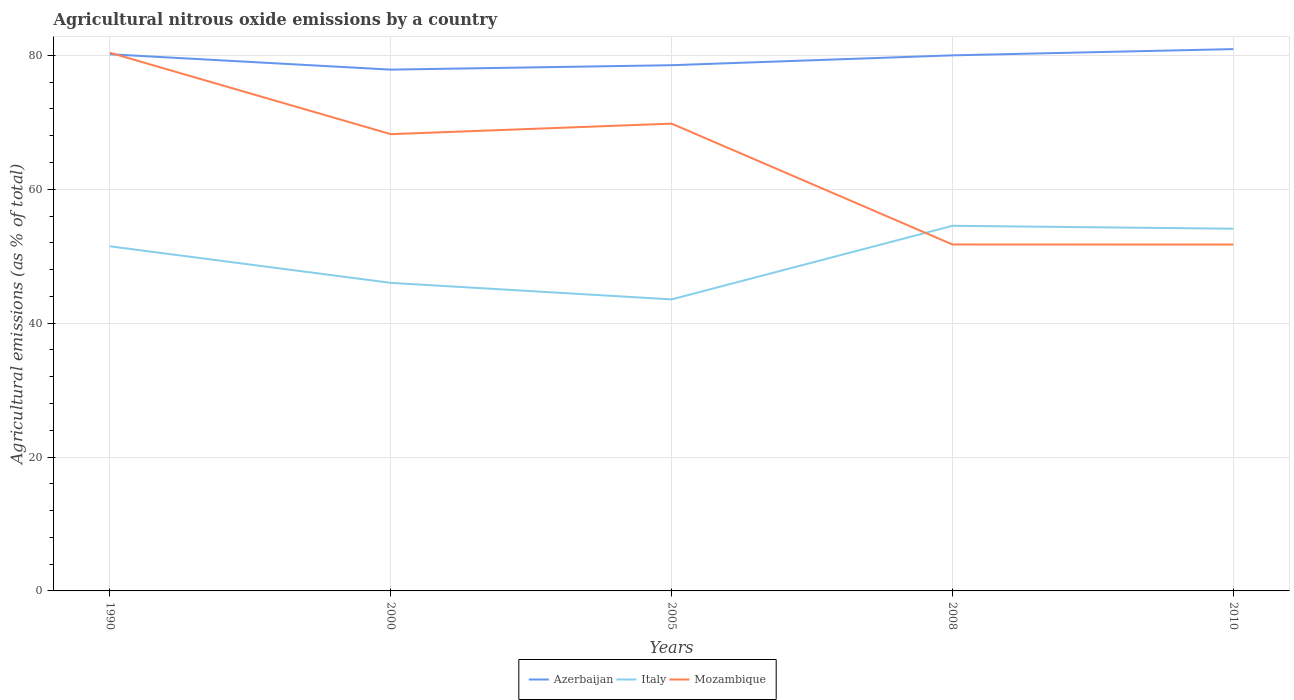Does the line corresponding to Azerbaijan intersect with the line corresponding to Mozambique?
Offer a terse response. Yes. Is the number of lines equal to the number of legend labels?
Ensure brevity in your answer.  Yes. Across all years, what is the maximum amount of agricultural nitrous oxide emitted in Italy?
Ensure brevity in your answer.  43.55. What is the total amount of agricultural nitrous oxide emitted in Mozambique in the graph?
Your response must be concise. 12.16. What is the difference between the highest and the second highest amount of agricultural nitrous oxide emitted in Italy?
Your answer should be very brief. 10.99. How many years are there in the graph?
Offer a terse response. 5. How many legend labels are there?
Your answer should be compact. 3. What is the title of the graph?
Your answer should be very brief. Agricultural nitrous oxide emissions by a country. Does "Isle of Man" appear as one of the legend labels in the graph?
Keep it short and to the point. No. What is the label or title of the X-axis?
Give a very brief answer. Years. What is the label or title of the Y-axis?
Offer a terse response. Agricultural emissions (as % of total). What is the Agricultural emissions (as % of total) in Azerbaijan in 1990?
Your answer should be very brief. 80.17. What is the Agricultural emissions (as % of total) of Italy in 1990?
Offer a terse response. 51.48. What is the Agricultural emissions (as % of total) in Mozambique in 1990?
Provide a succinct answer. 80.39. What is the Agricultural emissions (as % of total) of Azerbaijan in 2000?
Ensure brevity in your answer.  77.87. What is the Agricultural emissions (as % of total) in Italy in 2000?
Provide a succinct answer. 46.02. What is the Agricultural emissions (as % of total) in Mozambique in 2000?
Your response must be concise. 68.23. What is the Agricultural emissions (as % of total) of Azerbaijan in 2005?
Give a very brief answer. 78.53. What is the Agricultural emissions (as % of total) in Italy in 2005?
Make the answer very short. 43.55. What is the Agricultural emissions (as % of total) of Mozambique in 2005?
Offer a terse response. 69.8. What is the Agricultural emissions (as % of total) in Azerbaijan in 2008?
Provide a succinct answer. 80. What is the Agricultural emissions (as % of total) of Italy in 2008?
Ensure brevity in your answer.  54.54. What is the Agricultural emissions (as % of total) of Mozambique in 2008?
Provide a short and direct response. 51.75. What is the Agricultural emissions (as % of total) in Azerbaijan in 2010?
Your answer should be very brief. 80.94. What is the Agricultural emissions (as % of total) of Italy in 2010?
Provide a short and direct response. 54.1. What is the Agricultural emissions (as % of total) of Mozambique in 2010?
Your answer should be very brief. 51.74. Across all years, what is the maximum Agricultural emissions (as % of total) of Azerbaijan?
Ensure brevity in your answer.  80.94. Across all years, what is the maximum Agricultural emissions (as % of total) of Italy?
Ensure brevity in your answer.  54.54. Across all years, what is the maximum Agricultural emissions (as % of total) in Mozambique?
Your answer should be very brief. 80.39. Across all years, what is the minimum Agricultural emissions (as % of total) in Azerbaijan?
Provide a short and direct response. 77.87. Across all years, what is the minimum Agricultural emissions (as % of total) in Italy?
Offer a terse response. 43.55. Across all years, what is the minimum Agricultural emissions (as % of total) of Mozambique?
Offer a very short reply. 51.74. What is the total Agricultural emissions (as % of total) of Azerbaijan in the graph?
Offer a terse response. 397.51. What is the total Agricultural emissions (as % of total) of Italy in the graph?
Give a very brief answer. 249.69. What is the total Agricultural emissions (as % of total) in Mozambique in the graph?
Your answer should be compact. 321.92. What is the difference between the Agricultural emissions (as % of total) of Azerbaijan in 1990 and that in 2000?
Give a very brief answer. 2.3. What is the difference between the Agricultural emissions (as % of total) in Italy in 1990 and that in 2000?
Your answer should be compact. 5.46. What is the difference between the Agricultural emissions (as % of total) of Mozambique in 1990 and that in 2000?
Your answer should be compact. 12.16. What is the difference between the Agricultural emissions (as % of total) in Azerbaijan in 1990 and that in 2005?
Provide a short and direct response. 1.64. What is the difference between the Agricultural emissions (as % of total) in Italy in 1990 and that in 2005?
Your answer should be compact. 7.93. What is the difference between the Agricultural emissions (as % of total) of Mozambique in 1990 and that in 2005?
Offer a terse response. 10.59. What is the difference between the Agricultural emissions (as % of total) in Azerbaijan in 1990 and that in 2008?
Give a very brief answer. 0.16. What is the difference between the Agricultural emissions (as % of total) in Italy in 1990 and that in 2008?
Give a very brief answer. -3.06. What is the difference between the Agricultural emissions (as % of total) in Mozambique in 1990 and that in 2008?
Make the answer very short. 28.64. What is the difference between the Agricultural emissions (as % of total) of Azerbaijan in 1990 and that in 2010?
Your response must be concise. -0.77. What is the difference between the Agricultural emissions (as % of total) in Italy in 1990 and that in 2010?
Offer a terse response. -2.63. What is the difference between the Agricultural emissions (as % of total) in Mozambique in 1990 and that in 2010?
Offer a terse response. 28.65. What is the difference between the Agricultural emissions (as % of total) in Azerbaijan in 2000 and that in 2005?
Make the answer very short. -0.66. What is the difference between the Agricultural emissions (as % of total) of Italy in 2000 and that in 2005?
Your answer should be very brief. 2.47. What is the difference between the Agricultural emissions (as % of total) in Mozambique in 2000 and that in 2005?
Offer a very short reply. -1.57. What is the difference between the Agricultural emissions (as % of total) of Azerbaijan in 2000 and that in 2008?
Ensure brevity in your answer.  -2.13. What is the difference between the Agricultural emissions (as % of total) of Italy in 2000 and that in 2008?
Keep it short and to the point. -8.52. What is the difference between the Agricultural emissions (as % of total) of Mozambique in 2000 and that in 2008?
Offer a terse response. 16.48. What is the difference between the Agricultural emissions (as % of total) of Azerbaijan in 2000 and that in 2010?
Your response must be concise. -3.07. What is the difference between the Agricultural emissions (as % of total) in Italy in 2000 and that in 2010?
Offer a very short reply. -8.09. What is the difference between the Agricultural emissions (as % of total) in Mozambique in 2000 and that in 2010?
Ensure brevity in your answer.  16.49. What is the difference between the Agricultural emissions (as % of total) of Azerbaijan in 2005 and that in 2008?
Your response must be concise. -1.47. What is the difference between the Agricultural emissions (as % of total) in Italy in 2005 and that in 2008?
Your answer should be compact. -10.99. What is the difference between the Agricultural emissions (as % of total) of Mozambique in 2005 and that in 2008?
Make the answer very short. 18.05. What is the difference between the Agricultural emissions (as % of total) in Azerbaijan in 2005 and that in 2010?
Your answer should be compact. -2.41. What is the difference between the Agricultural emissions (as % of total) in Italy in 2005 and that in 2010?
Provide a succinct answer. -10.56. What is the difference between the Agricultural emissions (as % of total) of Mozambique in 2005 and that in 2010?
Your answer should be compact. 18.06. What is the difference between the Agricultural emissions (as % of total) of Azerbaijan in 2008 and that in 2010?
Provide a short and direct response. -0.93. What is the difference between the Agricultural emissions (as % of total) of Italy in 2008 and that in 2010?
Provide a succinct answer. 0.44. What is the difference between the Agricultural emissions (as % of total) of Mozambique in 2008 and that in 2010?
Ensure brevity in your answer.  0.01. What is the difference between the Agricultural emissions (as % of total) in Azerbaijan in 1990 and the Agricultural emissions (as % of total) in Italy in 2000?
Your response must be concise. 34.15. What is the difference between the Agricultural emissions (as % of total) in Azerbaijan in 1990 and the Agricultural emissions (as % of total) in Mozambique in 2000?
Provide a short and direct response. 11.94. What is the difference between the Agricultural emissions (as % of total) of Italy in 1990 and the Agricultural emissions (as % of total) of Mozambique in 2000?
Make the answer very short. -16.75. What is the difference between the Agricultural emissions (as % of total) of Azerbaijan in 1990 and the Agricultural emissions (as % of total) of Italy in 2005?
Ensure brevity in your answer.  36.62. What is the difference between the Agricultural emissions (as % of total) in Azerbaijan in 1990 and the Agricultural emissions (as % of total) in Mozambique in 2005?
Offer a terse response. 10.37. What is the difference between the Agricultural emissions (as % of total) in Italy in 1990 and the Agricultural emissions (as % of total) in Mozambique in 2005?
Give a very brief answer. -18.32. What is the difference between the Agricultural emissions (as % of total) in Azerbaijan in 1990 and the Agricultural emissions (as % of total) in Italy in 2008?
Keep it short and to the point. 25.63. What is the difference between the Agricultural emissions (as % of total) in Azerbaijan in 1990 and the Agricultural emissions (as % of total) in Mozambique in 2008?
Give a very brief answer. 28.42. What is the difference between the Agricultural emissions (as % of total) of Italy in 1990 and the Agricultural emissions (as % of total) of Mozambique in 2008?
Keep it short and to the point. -0.27. What is the difference between the Agricultural emissions (as % of total) in Azerbaijan in 1990 and the Agricultural emissions (as % of total) in Italy in 2010?
Your answer should be compact. 26.06. What is the difference between the Agricultural emissions (as % of total) in Azerbaijan in 1990 and the Agricultural emissions (as % of total) in Mozambique in 2010?
Provide a short and direct response. 28.42. What is the difference between the Agricultural emissions (as % of total) in Italy in 1990 and the Agricultural emissions (as % of total) in Mozambique in 2010?
Make the answer very short. -0.27. What is the difference between the Agricultural emissions (as % of total) of Azerbaijan in 2000 and the Agricultural emissions (as % of total) of Italy in 2005?
Your response must be concise. 34.32. What is the difference between the Agricultural emissions (as % of total) of Azerbaijan in 2000 and the Agricultural emissions (as % of total) of Mozambique in 2005?
Make the answer very short. 8.07. What is the difference between the Agricultural emissions (as % of total) of Italy in 2000 and the Agricultural emissions (as % of total) of Mozambique in 2005?
Ensure brevity in your answer.  -23.78. What is the difference between the Agricultural emissions (as % of total) of Azerbaijan in 2000 and the Agricultural emissions (as % of total) of Italy in 2008?
Your answer should be compact. 23.33. What is the difference between the Agricultural emissions (as % of total) of Azerbaijan in 2000 and the Agricultural emissions (as % of total) of Mozambique in 2008?
Ensure brevity in your answer.  26.12. What is the difference between the Agricultural emissions (as % of total) in Italy in 2000 and the Agricultural emissions (as % of total) in Mozambique in 2008?
Your answer should be very brief. -5.73. What is the difference between the Agricultural emissions (as % of total) of Azerbaijan in 2000 and the Agricultural emissions (as % of total) of Italy in 2010?
Provide a short and direct response. 23.77. What is the difference between the Agricultural emissions (as % of total) of Azerbaijan in 2000 and the Agricultural emissions (as % of total) of Mozambique in 2010?
Your response must be concise. 26.13. What is the difference between the Agricultural emissions (as % of total) of Italy in 2000 and the Agricultural emissions (as % of total) of Mozambique in 2010?
Offer a very short reply. -5.73. What is the difference between the Agricultural emissions (as % of total) of Azerbaijan in 2005 and the Agricultural emissions (as % of total) of Italy in 2008?
Offer a terse response. 23.99. What is the difference between the Agricultural emissions (as % of total) of Azerbaijan in 2005 and the Agricultural emissions (as % of total) of Mozambique in 2008?
Your answer should be compact. 26.78. What is the difference between the Agricultural emissions (as % of total) of Italy in 2005 and the Agricultural emissions (as % of total) of Mozambique in 2008?
Your response must be concise. -8.2. What is the difference between the Agricultural emissions (as % of total) of Azerbaijan in 2005 and the Agricultural emissions (as % of total) of Italy in 2010?
Give a very brief answer. 24.43. What is the difference between the Agricultural emissions (as % of total) in Azerbaijan in 2005 and the Agricultural emissions (as % of total) in Mozambique in 2010?
Ensure brevity in your answer.  26.79. What is the difference between the Agricultural emissions (as % of total) in Italy in 2005 and the Agricultural emissions (as % of total) in Mozambique in 2010?
Provide a succinct answer. -8.19. What is the difference between the Agricultural emissions (as % of total) of Azerbaijan in 2008 and the Agricultural emissions (as % of total) of Italy in 2010?
Give a very brief answer. 25.9. What is the difference between the Agricultural emissions (as % of total) in Azerbaijan in 2008 and the Agricultural emissions (as % of total) in Mozambique in 2010?
Make the answer very short. 28.26. What is the difference between the Agricultural emissions (as % of total) in Italy in 2008 and the Agricultural emissions (as % of total) in Mozambique in 2010?
Your answer should be very brief. 2.8. What is the average Agricultural emissions (as % of total) of Azerbaijan per year?
Your response must be concise. 79.5. What is the average Agricultural emissions (as % of total) in Italy per year?
Provide a succinct answer. 49.94. What is the average Agricultural emissions (as % of total) in Mozambique per year?
Your response must be concise. 64.38. In the year 1990, what is the difference between the Agricultural emissions (as % of total) of Azerbaijan and Agricultural emissions (as % of total) of Italy?
Provide a succinct answer. 28.69. In the year 1990, what is the difference between the Agricultural emissions (as % of total) in Azerbaijan and Agricultural emissions (as % of total) in Mozambique?
Keep it short and to the point. -0.22. In the year 1990, what is the difference between the Agricultural emissions (as % of total) in Italy and Agricultural emissions (as % of total) in Mozambique?
Ensure brevity in your answer.  -28.91. In the year 2000, what is the difference between the Agricultural emissions (as % of total) of Azerbaijan and Agricultural emissions (as % of total) of Italy?
Give a very brief answer. 31.85. In the year 2000, what is the difference between the Agricultural emissions (as % of total) in Azerbaijan and Agricultural emissions (as % of total) in Mozambique?
Ensure brevity in your answer.  9.64. In the year 2000, what is the difference between the Agricultural emissions (as % of total) of Italy and Agricultural emissions (as % of total) of Mozambique?
Your answer should be very brief. -22.21. In the year 2005, what is the difference between the Agricultural emissions (as % of total) of Azerbaijan and Agricultural emissions (as % of total) of Italy?
Provide a succinct answer. 34.98. In the year 2005, what is the difference between the Agricultural emissions (as % of total) in Azerbaijan and Agricultural emissions (as % of total) in Mozambique?
Give a very brief answer. 8.73. In the year 2005, what is the difference between the Agricultural emissions (as % of total) of Italy and Agricultural emissions (as % of total) of Mozambique?
Offer a terse response. -26.25. In the year 2008, what is the difference between the Agricultural emissions (as % of total) of Azerbaijan and Agricultural emissions (as % of total) of Italy?
Make the answer very short. 25.46. In the year 2008, what is the difference between the Agricultural emissions (as % of total) of Azerbaijan and Agricultural emissions (as % of total) of Mozambique?
Give a very brief answer. 28.25. In the year 2008, what is the difference between the Agricultural emissions (as % of total) in Italy and Agricultural emissions (as % of total) in Mozambique?
Offer a terse response. 2.79. In the year 2010, what is the difference between the Agricultural emissions (as % of total) in Azerbaijan and Agricultural emissions (as % of total) in Italy?
Provide a succinct answer. 26.83. In the year 2010, what is the difference between the Agricultural emissions (as % of total) of Azerbaijan and Agricultural emissions (as % of total) of Mozambique?
Your answer should be very brief. 29.19. In the year 2010, what is the difference between the Agricultural emissions (as % of total) of Italy and Agricultural emissions (as % of total) of Mozambique?
Offer a very short reply. 2.36. What is the ratio of the Agricultural emissions (as % of total) in Azerbaijan in 1990 to that in 2000?
Make the answer very short. 1.03. What is the ratio of the Agricultural emissions (as % of total) in Italy in 1990 to that in 2000?
Provide a short and direct response. 1.12. What is the ratio of the Agricultural emissions (as % of total) in Mozambique in 1990 to that in 2000?
Make the answer very short. 1.18. What is the ratio of the Agricultural emissions (as % of total) of Azerbaijan in 1990 to that in 2005?
Offer a very short reply. 1.02. What is the ratio of the Agricultural emissions (as % of total) of Italy in 1990 to that in 2005?
Your response must be concise. 1.18. What is the ratio of the Agricultural emissions (as % of total) in Mozambique in 1990 to that in 2005?
Your response must be concise. 1.15. What is the ratio of the Agricultural emissions (as % of total) in Azerbaijan in 1990 to that in 2008?
Make the answer very short. 1. What is the ratio of the Agricultural emissions (as % of total) in Italy in 1990 to that in 2008?
Give a very brief answer. 0.94. What is the ratio of the Agricultural emissions (as % of total) of Mozambique in 1990 to that in 2008?
Offer a terse response. 1.55. What is the ratio of the Agricultural emissions (as % of total) of Italy in 1990 to that in 2010?
Give a very brief answer. 0.95. What is the ratio of the Agricultural emissions (as % of total) of Mozambique in 1990 to that in 2010?
Provide a short and direct response. 1.55. What is the ratio of the Agricultural emissions (as % of total) of Azerbaijan in 2000 to that in 2005?
Offer a very short reply. 0.99. What is the ratio of the Agricultural emissions (as % of total) in Italy in 2000 to that in 2005?
Ensure brevity in your answer.  1.06. What is the ratio of the Agricultural emissions (as % of total) in Mozambique in 2000 to that in 2005?
Provide a succinct answer. 0.98. What is the ratio of the Agricultural emissions (as % of total) in Azerbaijan in 2000 to that in 2008?
Make the answer very short. 0.97. What is the ratio of the Agricultural emissions (as % of total) in Italy in 2000 to that in 2008?
Your response must be concise. 0.84. What is the ratio of the Agricultural emissions (as % of total) in Mozambique in 2000 to that in 2008?
Provide a short and direct response. 1.32. What is the ratio of the Agricultural emissions (as % of total) of Azerbaijan in 2000 to that in 2010?
Keep it short and to the point. 0.96. What is the ratio of the Agricultural emissions (as % of total) in Italy in 2000 to that in 2010?
Offer a very short reply. 0.85. What is the ratio of the Agricultural emissions (as % of total) of Mozambique in 2000 to that in 2010?
Your response must be concise. 1.32. What is the ratio of the Agricultural emissions (as % of total) of Azerbaijan in 2005 to that in 2008?
Provide a succinct answer. 0.98. What is the ratio of the Agricultural emissions (as % of total) in Italy in 2005 to that in 2008?
Your response must be concise. 0.8. What is the ratio of the Agricultural emissions (as % of total) in Mozambique in 2005 to that in 2008?
Your answer should be compact. 1.35. What is the ratio of the Agricultural emissions (as % of total) in Azerbaijan in 2005 to that in 2010?
Ensure brevity in your answer.  0.97. What is the ratio of the Agricultural emissions (as % of total) in Italy in 2005 to that in 2010?
Give a very brief answer. 0.8. What is the ratio of the Agricultural emissions (as % of total) of Mozambique in 2005 to that in 2010?
Give a very brief answer. 1.35. What is the ratio of the Agricultural emissions (as % of total) of Mozambique in 2008 to that in 2010?
Keep it short and to the point. 1. What is the difference between the highest and the second highest Agricultural emissions (as % of total) of Azerbaijan?
Ensure brevity in your answer.  0.77. What is the difference between the highest and the second highest Agricultural emissions (as % of total) of Italy?
Offer a terse response. 0.44. What is the difference between the highest and the second highest Agricultural emissions (as % of total) in Mozambique?
Offer a very short reply. 10.59. What is the difference between the highest and the lowest Agricultural emissions (as % of total) in Azerbaijan?
Make the answer very short. 3.07. What is the difference between the highest and the lowest Agricultural emissions (as % of total) in Italy?
Provide a succinct answer. 10.99. What is the difference between the highest and the lowest Agricultural emissions (as % of total) of Mozambique?
Offer a very short reply. 28.65. 